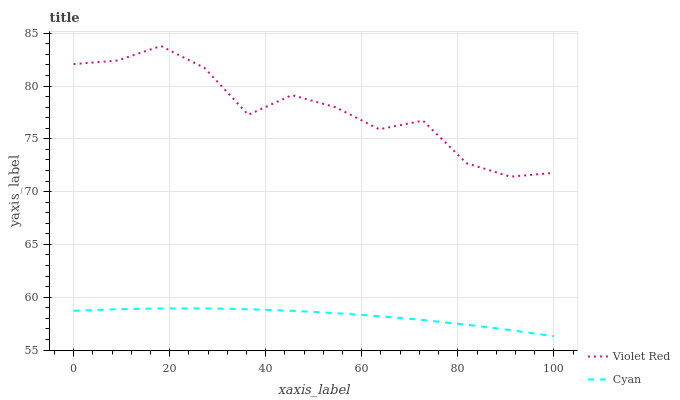Does Violet Red have the minimum area under the curve?
Answer yes or no. No. Is Violet Red the smoothest?
Answer yes or no. No. Does Violet Red have the lowest value?
Answer yes or no. No. Is Cyan less than Violet Red?
Answer yes or no. Yes. Is Violet Red greater than Cyan?
Answer yes or no. Yes. Does Cyan intersect Violet Red?
Answer yes or no. No. 